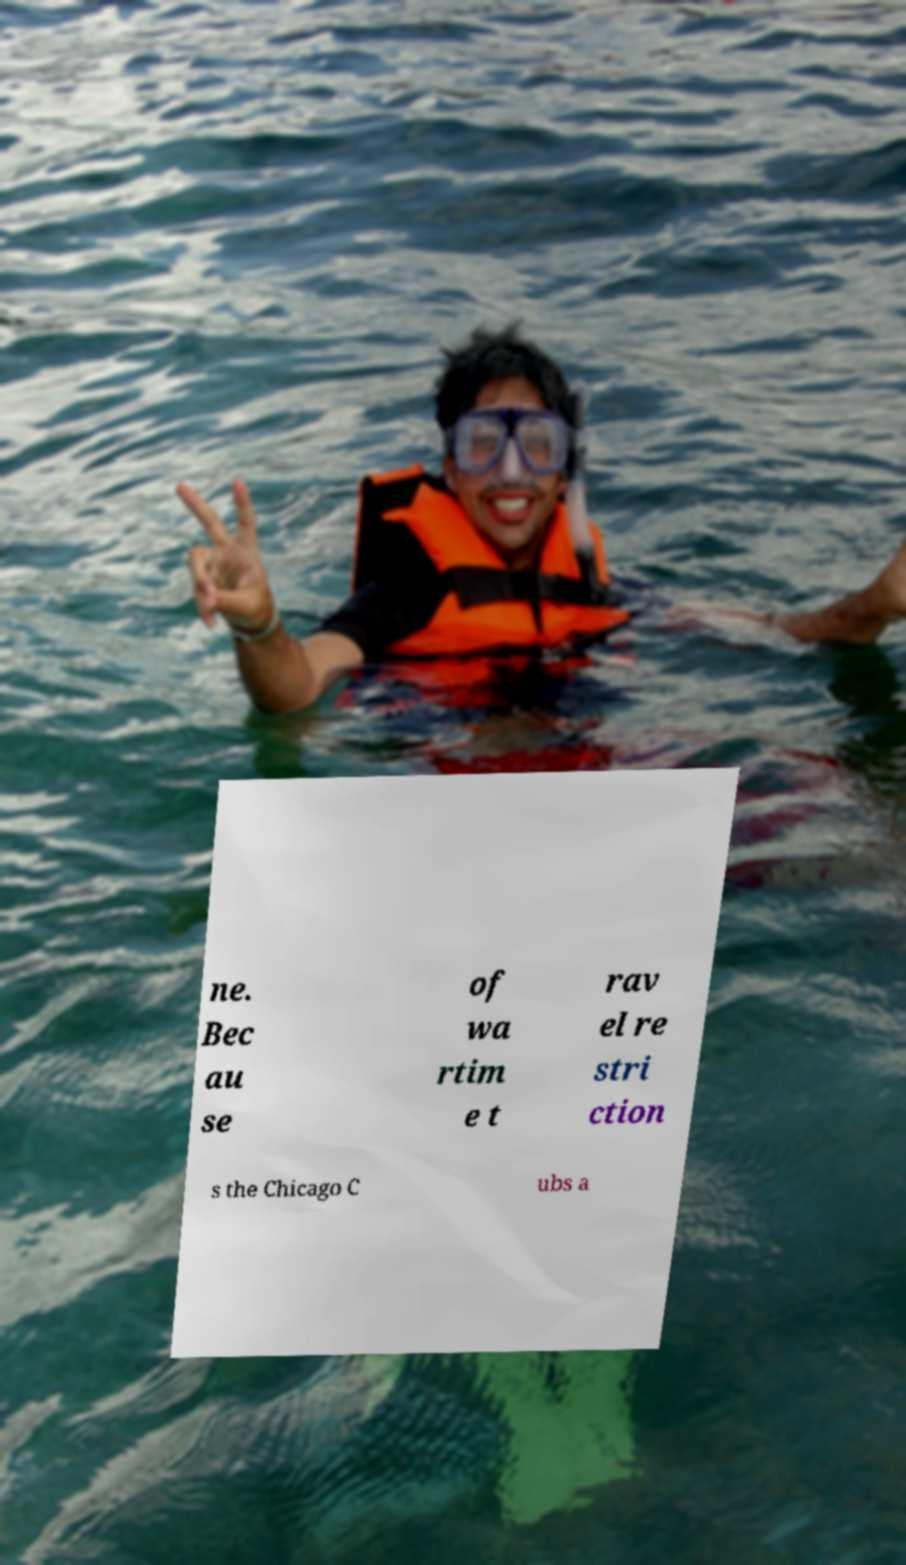Could you extract and type out the text from this image? ne. Bec au se of wa rtim e t rav el re stri ction s the Chicago C ubs a 